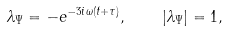<formula> <loc_0><loc_0><loc_500><loc_500>\lambda _ { \Psi } = - e ^ { - 3 i \omega ( t + \tau ) } , \quad | \lambda _ { \Psi } | = 1 ,</formula> 